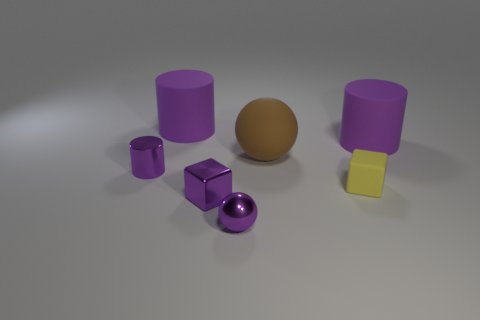There is a metal cylinder that is the same color as the tiny shiny block; what is its size?
Offer a very short reply. Small. There is a object that is both on the right side of the tiny shiny sphere and in front of the rubber ball; what size is it?
Your answer should be compact. Small. Is the rubber cube the same size as the brown matte ball?
Provide a short and direct response. No. Does the sphere behind the purple metallic cube have the same color as the small matte block?
Offer a very short reply. No. There is a small ball; how many large cylinders are to the left of it?
Ensure brevity in your answer.  1. Are there more matte cubes than purple rubber things?
Ensure brevity in your answer.  No. What is the shape of the object that is both to the right of the brown sphere and behind the big brown object?
Make the answer very short. Cylinder. Is there a small green matte cube?
Your answer should be compact. No. What material is the other tiny object that is the same shape as the yellow thing?
Ensure brevity in your answer.  Metal. The large purple thing in front of the big purple cylinder that is left of the cube in front of the yellow matte cube is what shape?
Give a very brief answer. Cylinder. 